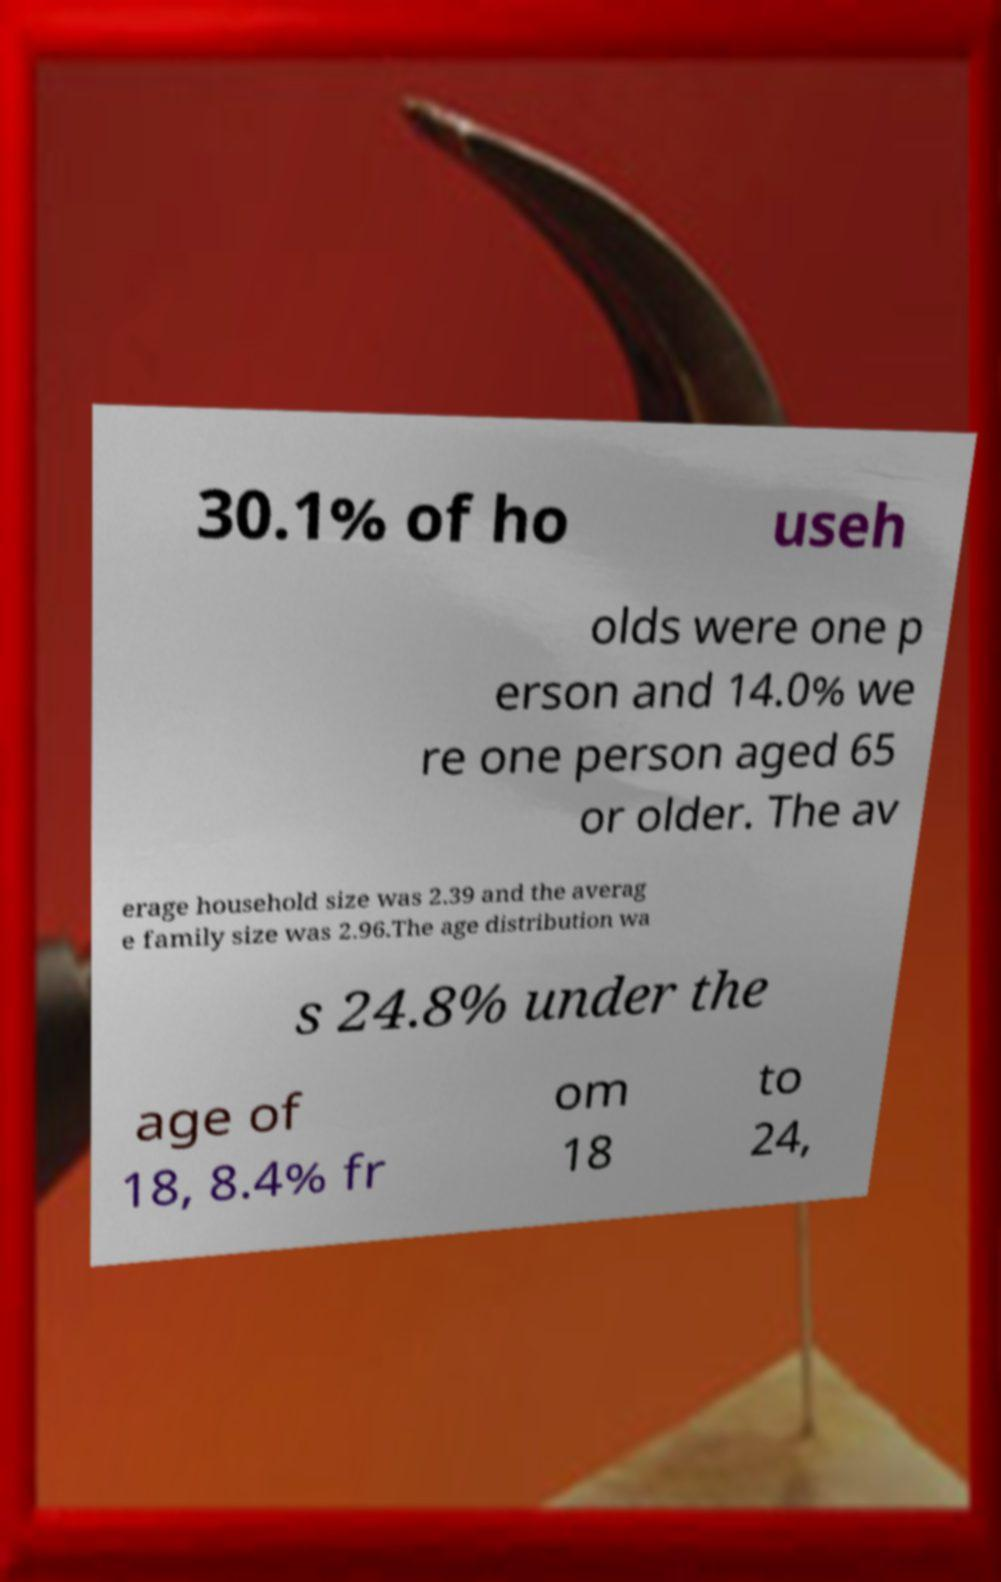Could you assist in decoding the text presented in this image and type it out clearly? 30.1% of ho useh olds were one p erson and 14.0% we re one person aged 65 or older. The av erage household size was 2.39 and the averag e family size was 2.96.The age distribution wa s 24.8% under the age of 18, 8.4% fr om 18 to 24, 